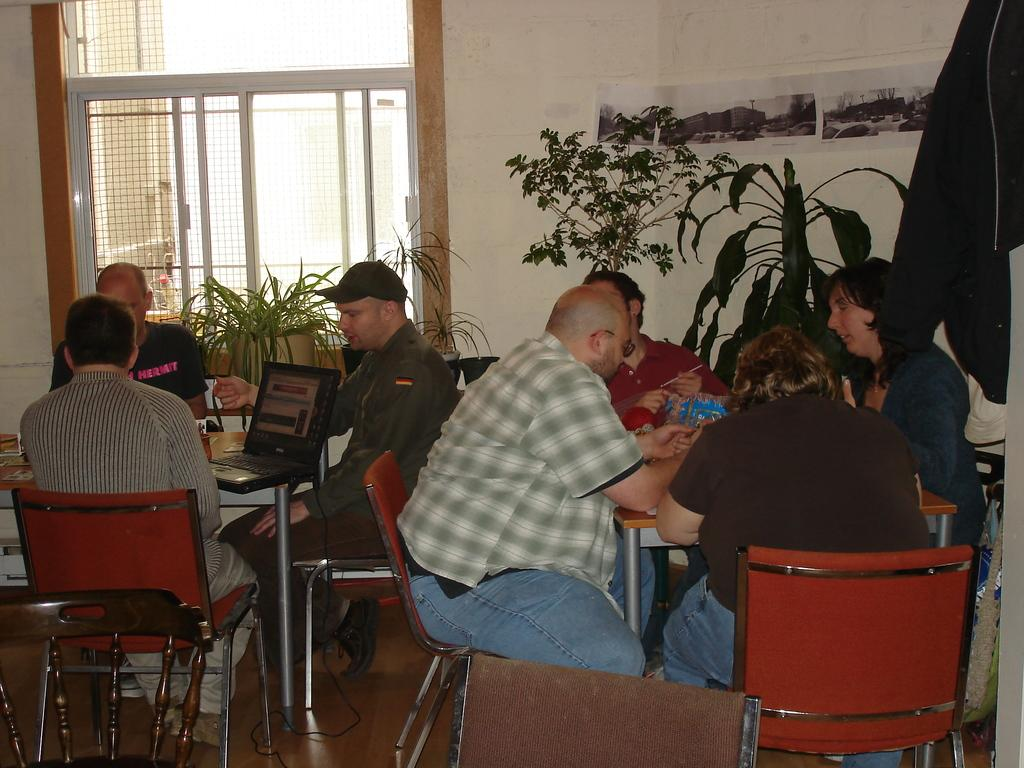What are the people in the image doing? The people in the image are sitting on chairs. What is on the table in the image? There is a laptop present on the table. What else can be seen in the image besides the people and the table? There are plants visible in the image. What type of flame can be seen coming from the laptop in the image? There is no flame present in the image; the laptop is not on fire. What type of work is being done on the laptop in the image? The image does not provide any information about the work being done on the laptop, as it only shows the laptop's presence on the table. 